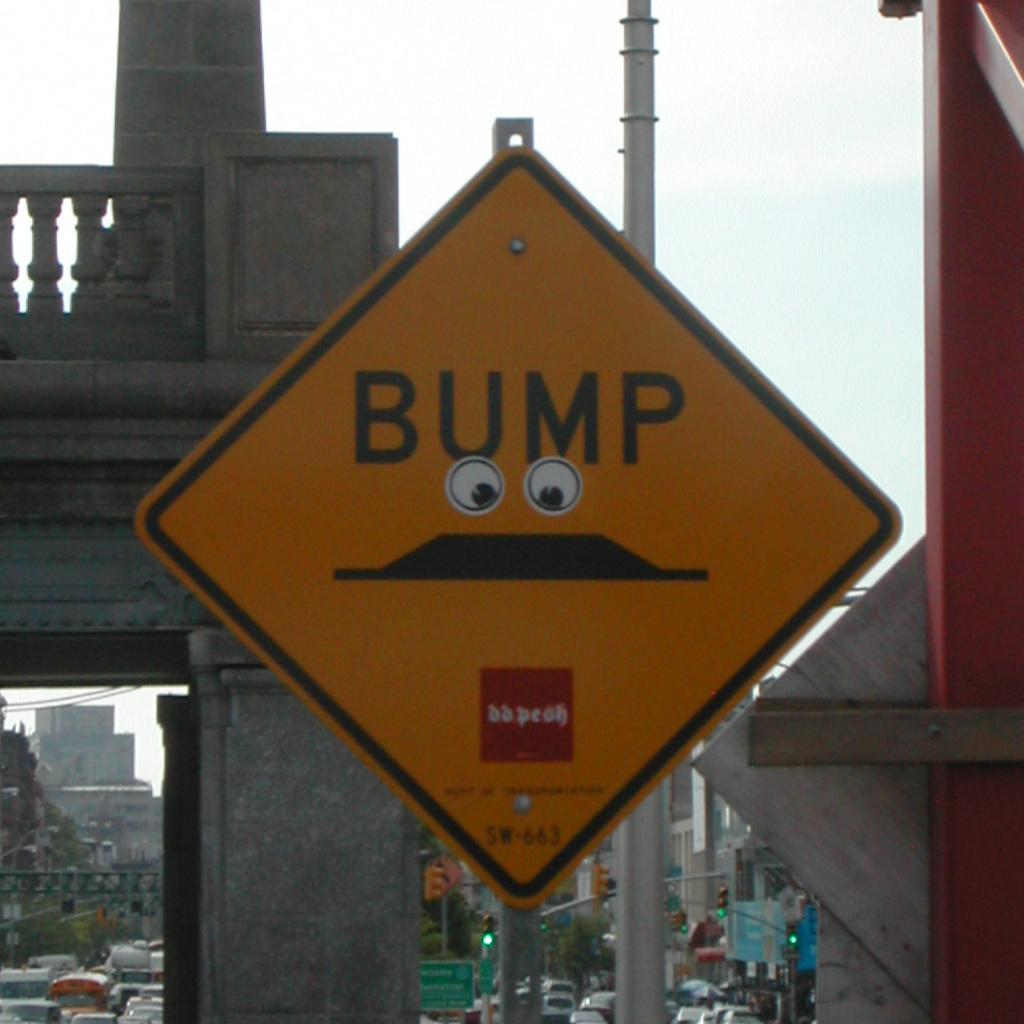<image>
Present a compact description of the photo's key features. Someone has placed sticker eyes on a "Bump" road sign. 